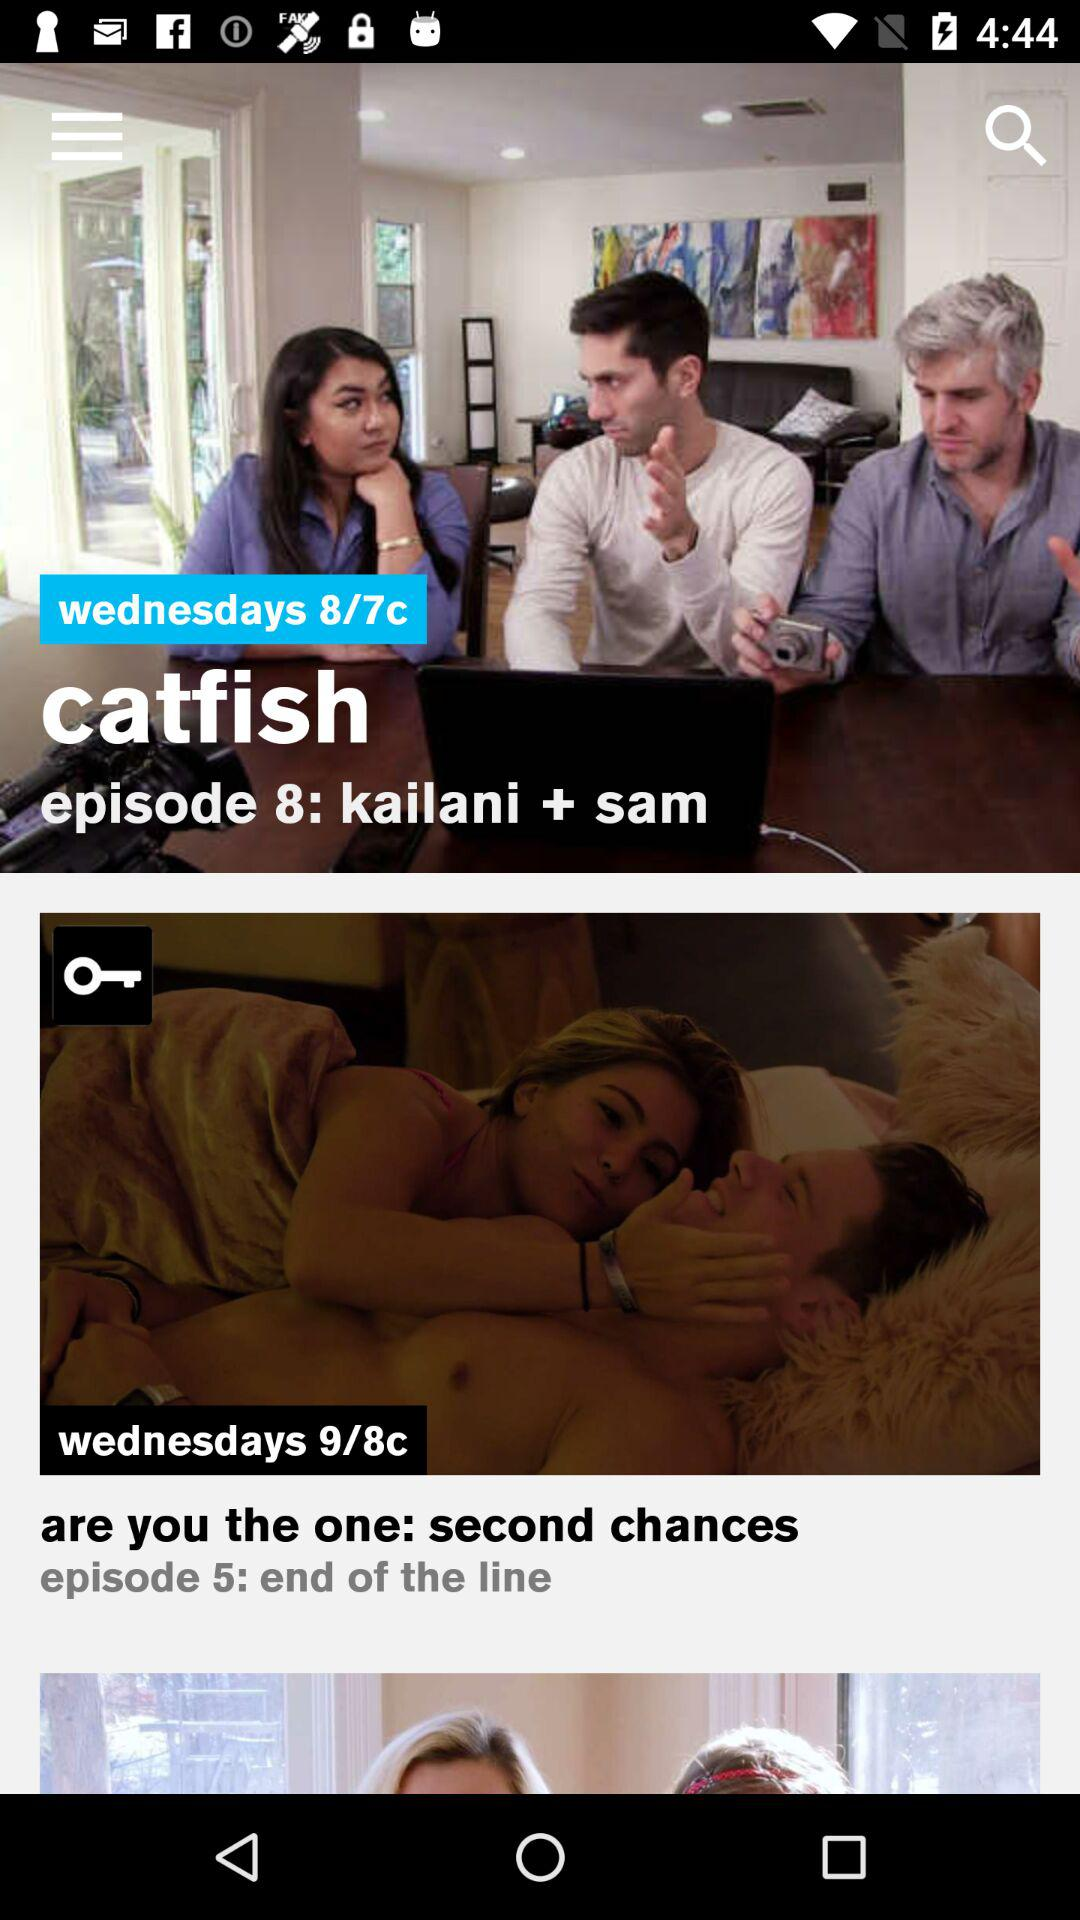Which day is given for Episode 8? The day given for Episode 8 is Wednesday. 